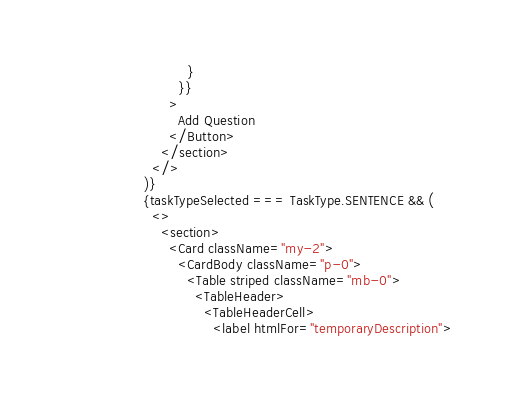Convert code to text. <code><loc_0><loc_0><loc_500><loc_500><_JavaScript_>                    }
                  }}
                >
                  Add Question
                </Button>
              </section>
            </>
          )}
          {taskTypeSelected === TaskType.SENTENCE && (
            <>
              <section>
                <Card className="my-2">
                  <CardBody className="p-0">
                    <Table striped className="mb-0">
                      <TableHeader>
                        <TableHeaderCell>
                          <label htmlFor="temporaryDescription"></code> 